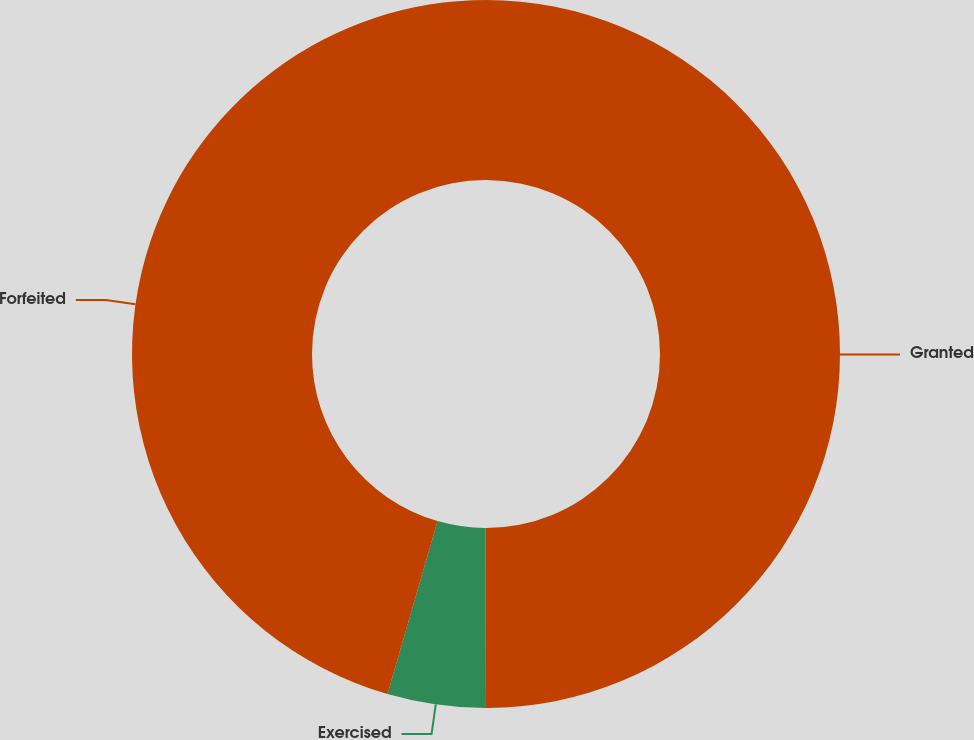Convert chart. <chart><loc_0><loc_0><loc_500><loc_500><pie_chart><fcel>Granted<fcel>Exercised<fcel>Forfeited<nl><fcel>50.04%<fcel>4.45%<fcel>45.51%<nl></chart> 